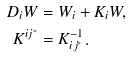Convert formula to latex. <formula><loc_0><loc_0><loc_500><loc_500>D _ { i } W & = W _ { i } + K _ { i } W , \\ K ^ { i j ^ { * } } & = K _ { i j ^ { * } } ^ { - 1 } .</formula> 